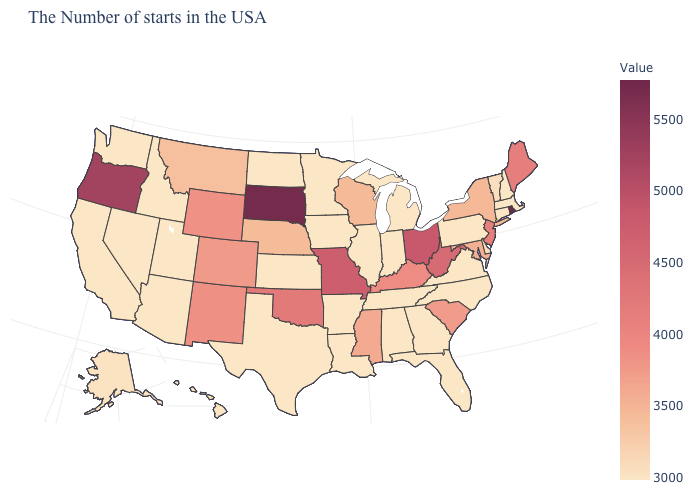Which states have the highest value in the USA?
Concise answer only. Rhode Island. Does New Mexico have a higher value than Indiana?
Write a very short answer. Yes. Does Michigan have the highest value in the MidWest?
Be succinct. No. Which states have the lowest value in the USA?
Concise answer only. Massachusetts, New Hampshire, Connecticut, Pennsylvania, Virginia, North Carolina, Florida, Georgia, Michigan, Indiana, Alabama, Tennessee, Illinois, Louisiana, Arkansas, Minnesota, Iowa, Kansas, Texas, North Dakota, Utah, Arizona, Idaho, Nevada, California, Washington, Hawaii. Which states have the highest value in the USA?
Be succinct. Rhode Island. 